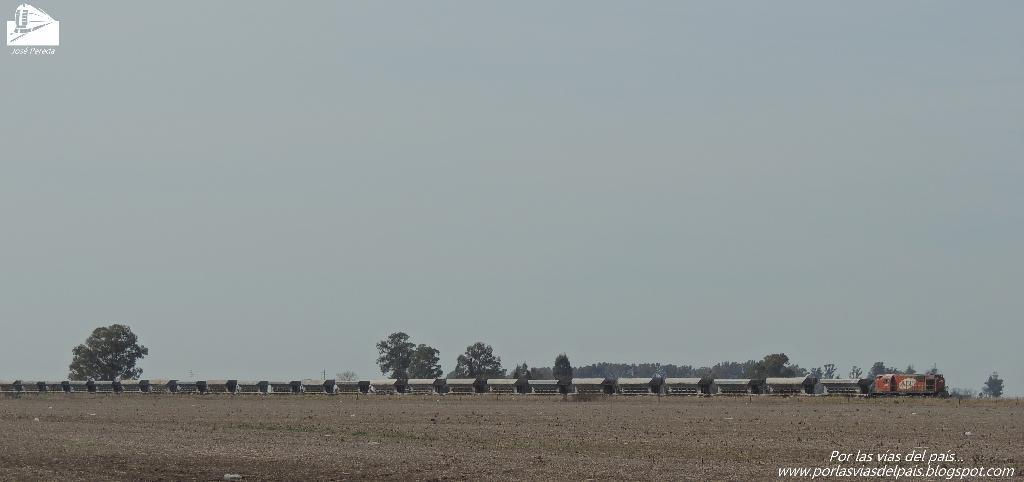What is the main subject of the image? There is a train in the image. What type of natural environment is visible in the image? There are trees in the image. What can be seen at the bottom of the image? The ground is visible at the bottom of the image. How many knots are tied in the train's tracks in the image? There are no knots present in the image, as the train's tracks are not tied. What type of sand can be seen on the ground in the image? There is no sand visible in the image; the ground is not made of sand. 